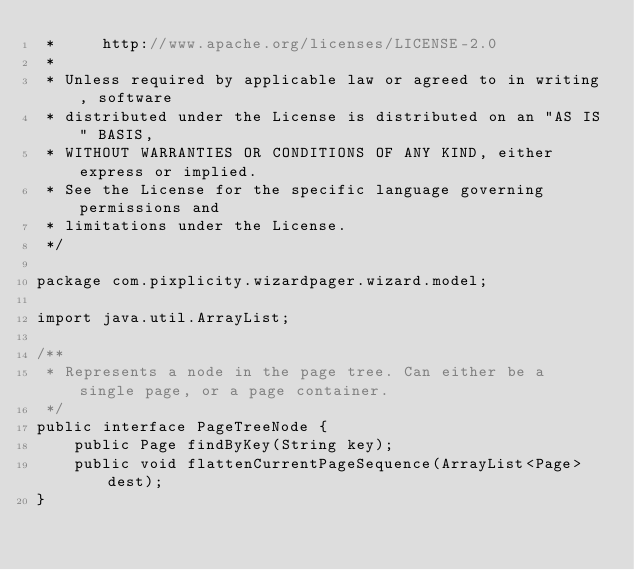Convert code to text. <code><loc_0><loc_0><loc_500><loc_500><_Java_> *     http://www.apache.org/licenses/LICENSE-2.0
 *
 * Unless required by applicable law or agreed to in writing, software
 * distributed under the License is distributed on an "AS IS" BASIS,
 * WITHOUT WARRANTIES OR CONDITIONS OF ANY KIND, either express or implied.
 * See the License for the specific language governing permissions and
 * limitations under the License.
 */

package com.pixplicity.wizardpager.wizard.model;

import java.util.ArrayList;

/**
 * Represents a node in the page tree. Can either be a single page, or a page container.
 */
public interface PageTreeNode {
    public Page findByKey(String key);
    public void flattenCurrentPageSequence(ArrayList<Page> dest);
}
</code> 